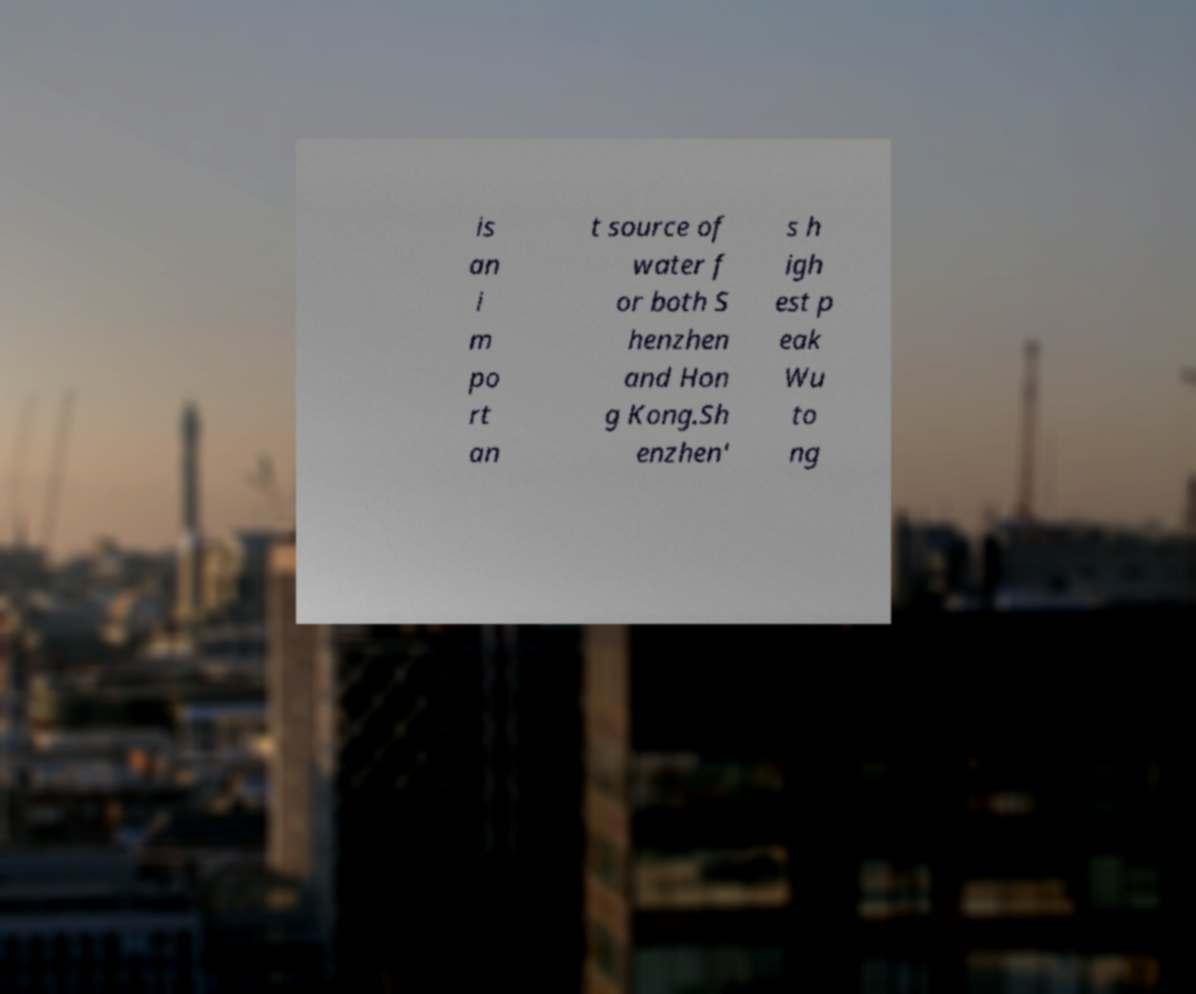Can you accurately transcribe the text from the provided image for me? is an i m po rt an t source of water f or both S henzhen and Hon g Kong.Sh enzhen' s h igh est p eak Wu to ng 